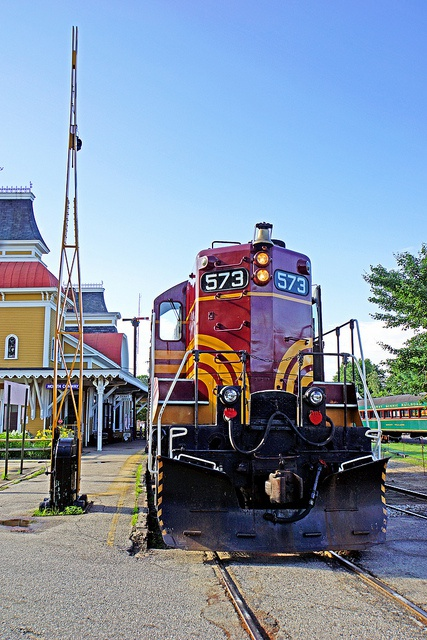Describe the objects in this image and their specific colors. I can see train in lightblue, black, navy, purple, and white tones and train in lightblue, black, teal, and darkgray tones in this image. 